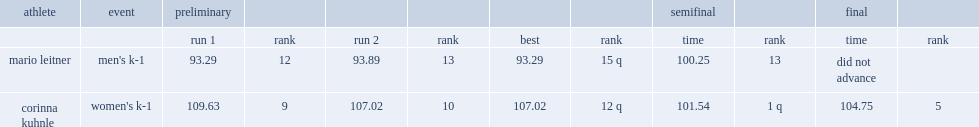What was the result that corinna kuhnle got in the semifinal? 101.54. 